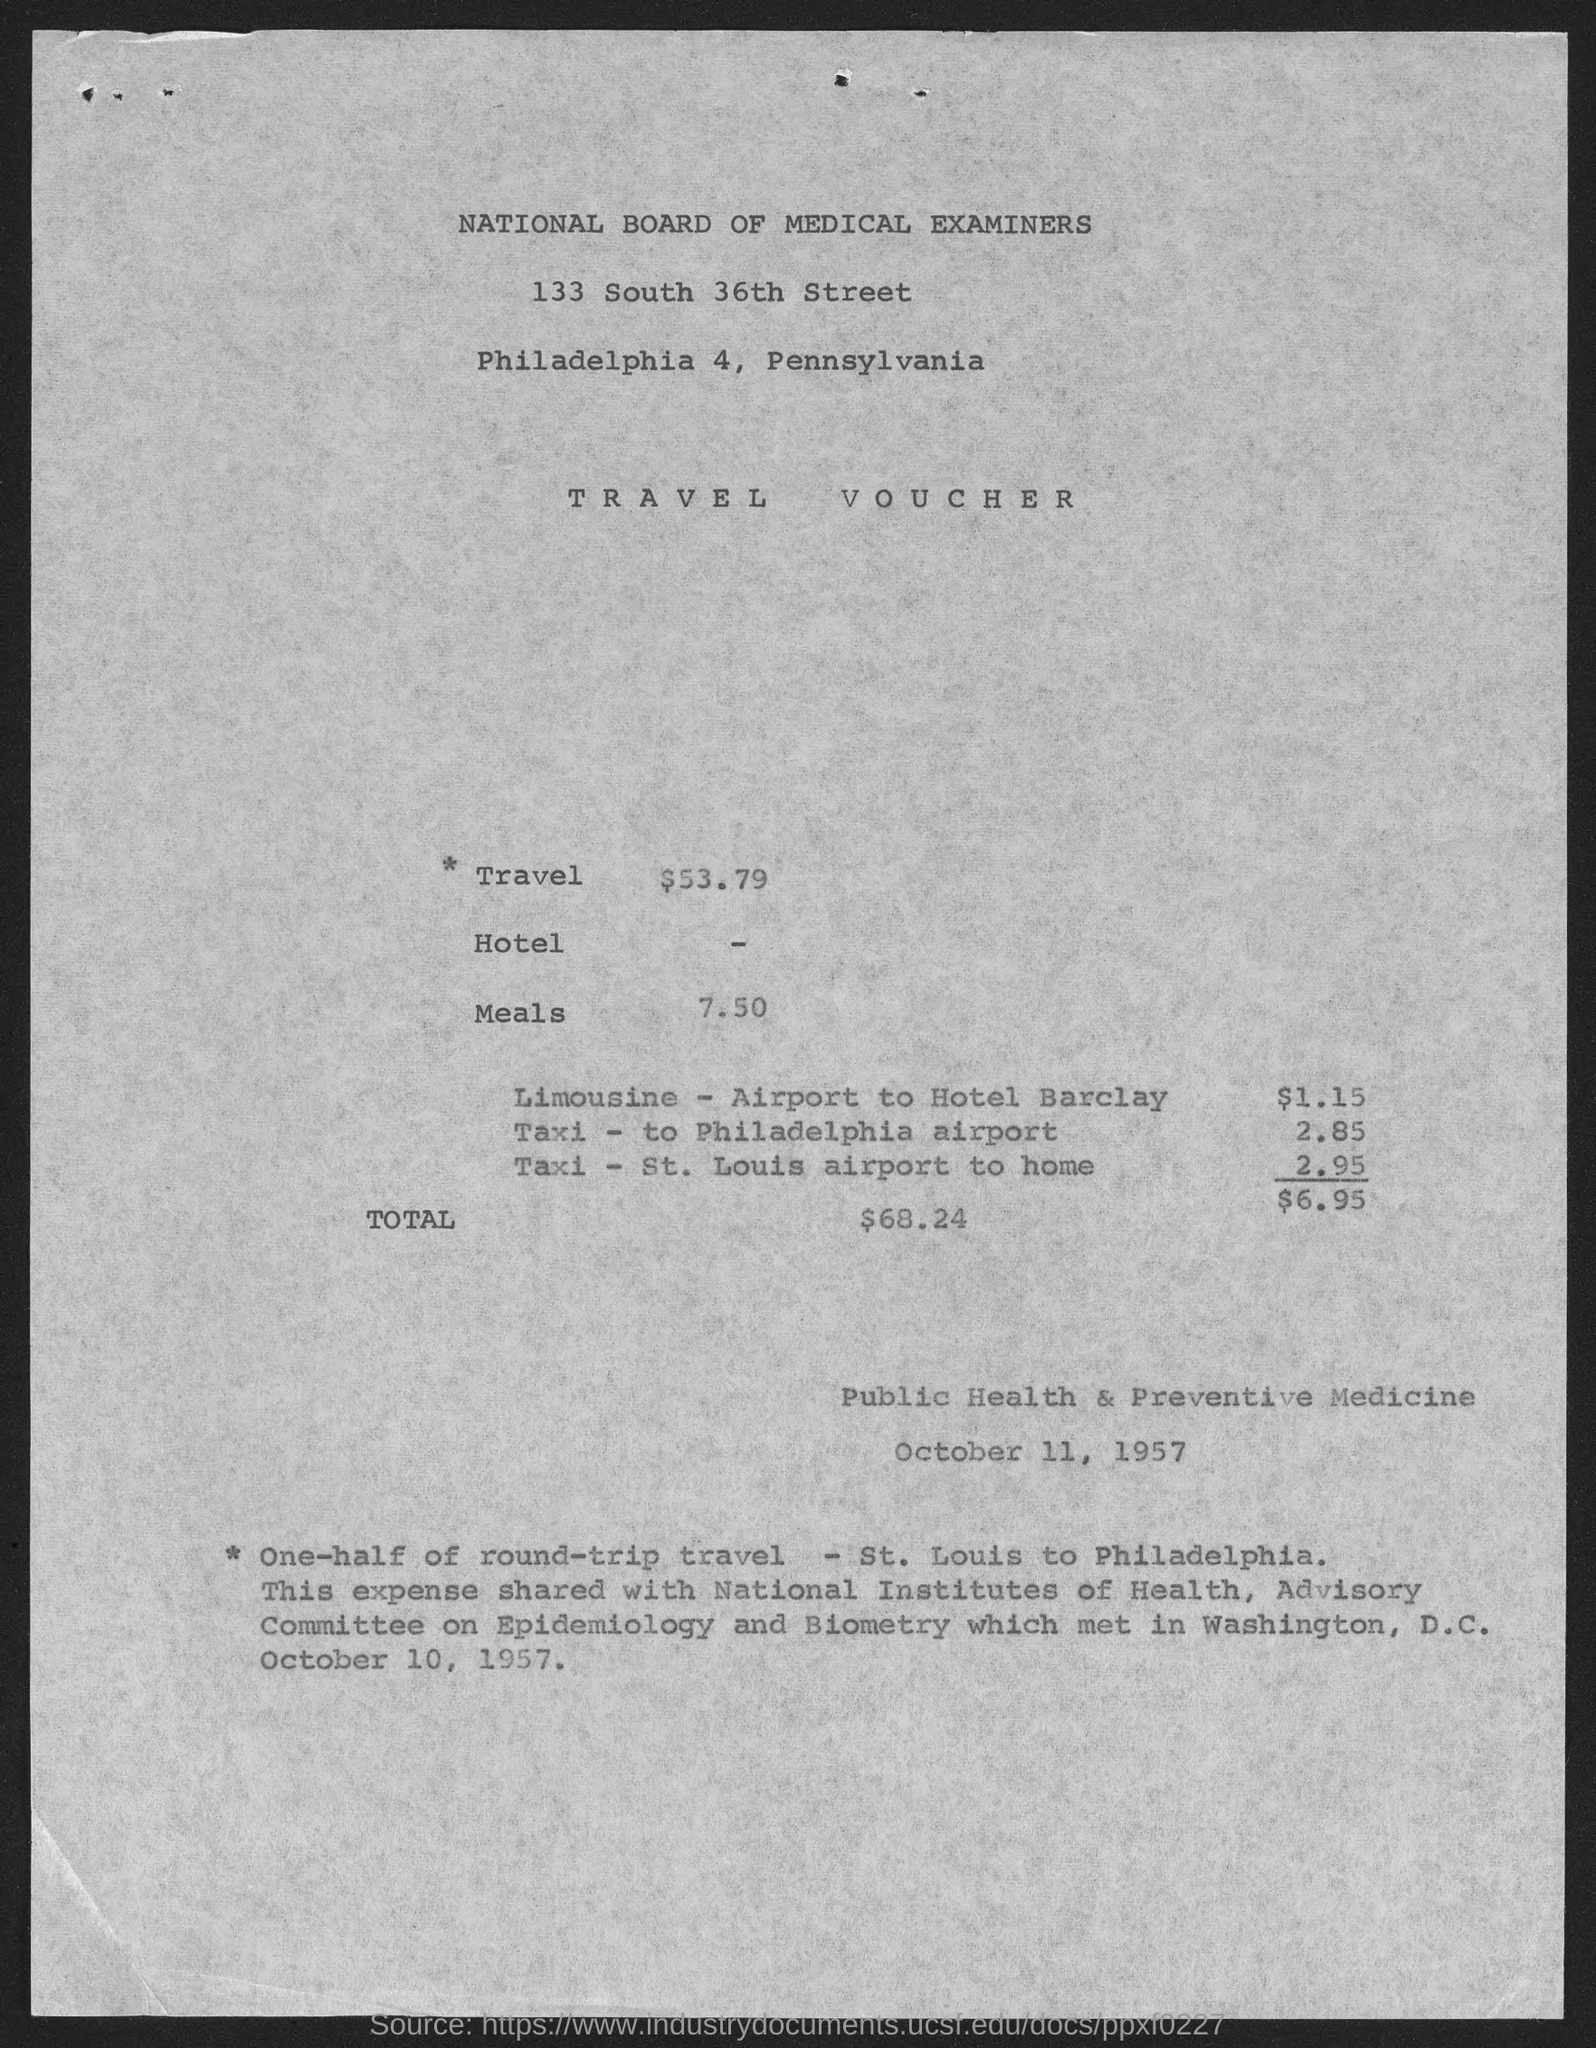What is the date?
Keep it short and to the point. OCTOBER 11, 1957. What is the document about?
Provide a succinct answer. TRAVEL VOUCHER. 